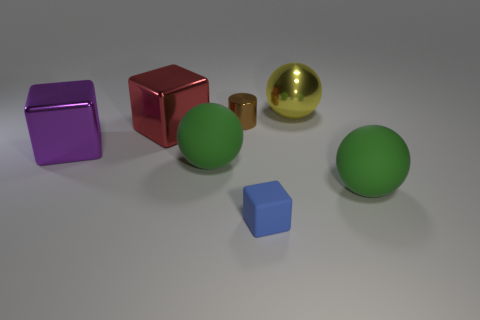How many blue matte blocks are the same size as the purple shiny cube?
Your response must be concise. 0. There is a green matte object that is to the right of the small brown thing; how many green things are in front of it?
Your answer should be very brief. 0. Is the tiny thing behind the blue block made of the same material as the purple thing?
Give a very brief answer. Yes. Are the large cube that is behind the big purple cube and the green object that is to the left of the large yellow ball made of the same material?
Your answer should be very brief. No. Are there more purple objects that are to the right of the brown metallic cylinder than tiny metallic cylinders?
Give a very brief answer. No. What color is the big rubber sphere that is on the right side of the green matte object that is to the left of the metallic cylinder?
Offer a very short reply. Green. There is a blue object that is the same size as the brown shiny cylinder; what is its shape?
Provide a short and direct response. Cube. Is the number of green rubber things the same as the number of large yellow shiny balls?
Keep it short and to the point. No. Is the number of objects that are on the left side of the blue object the same as the number of brown shiny objects?
Your answer should be compact. No. There is a tiny thing behind the big green rubber sphere that is right of the green ball to the left of the small brown shiny cylinder; what is its material?
Your response must be concise. Metal. 